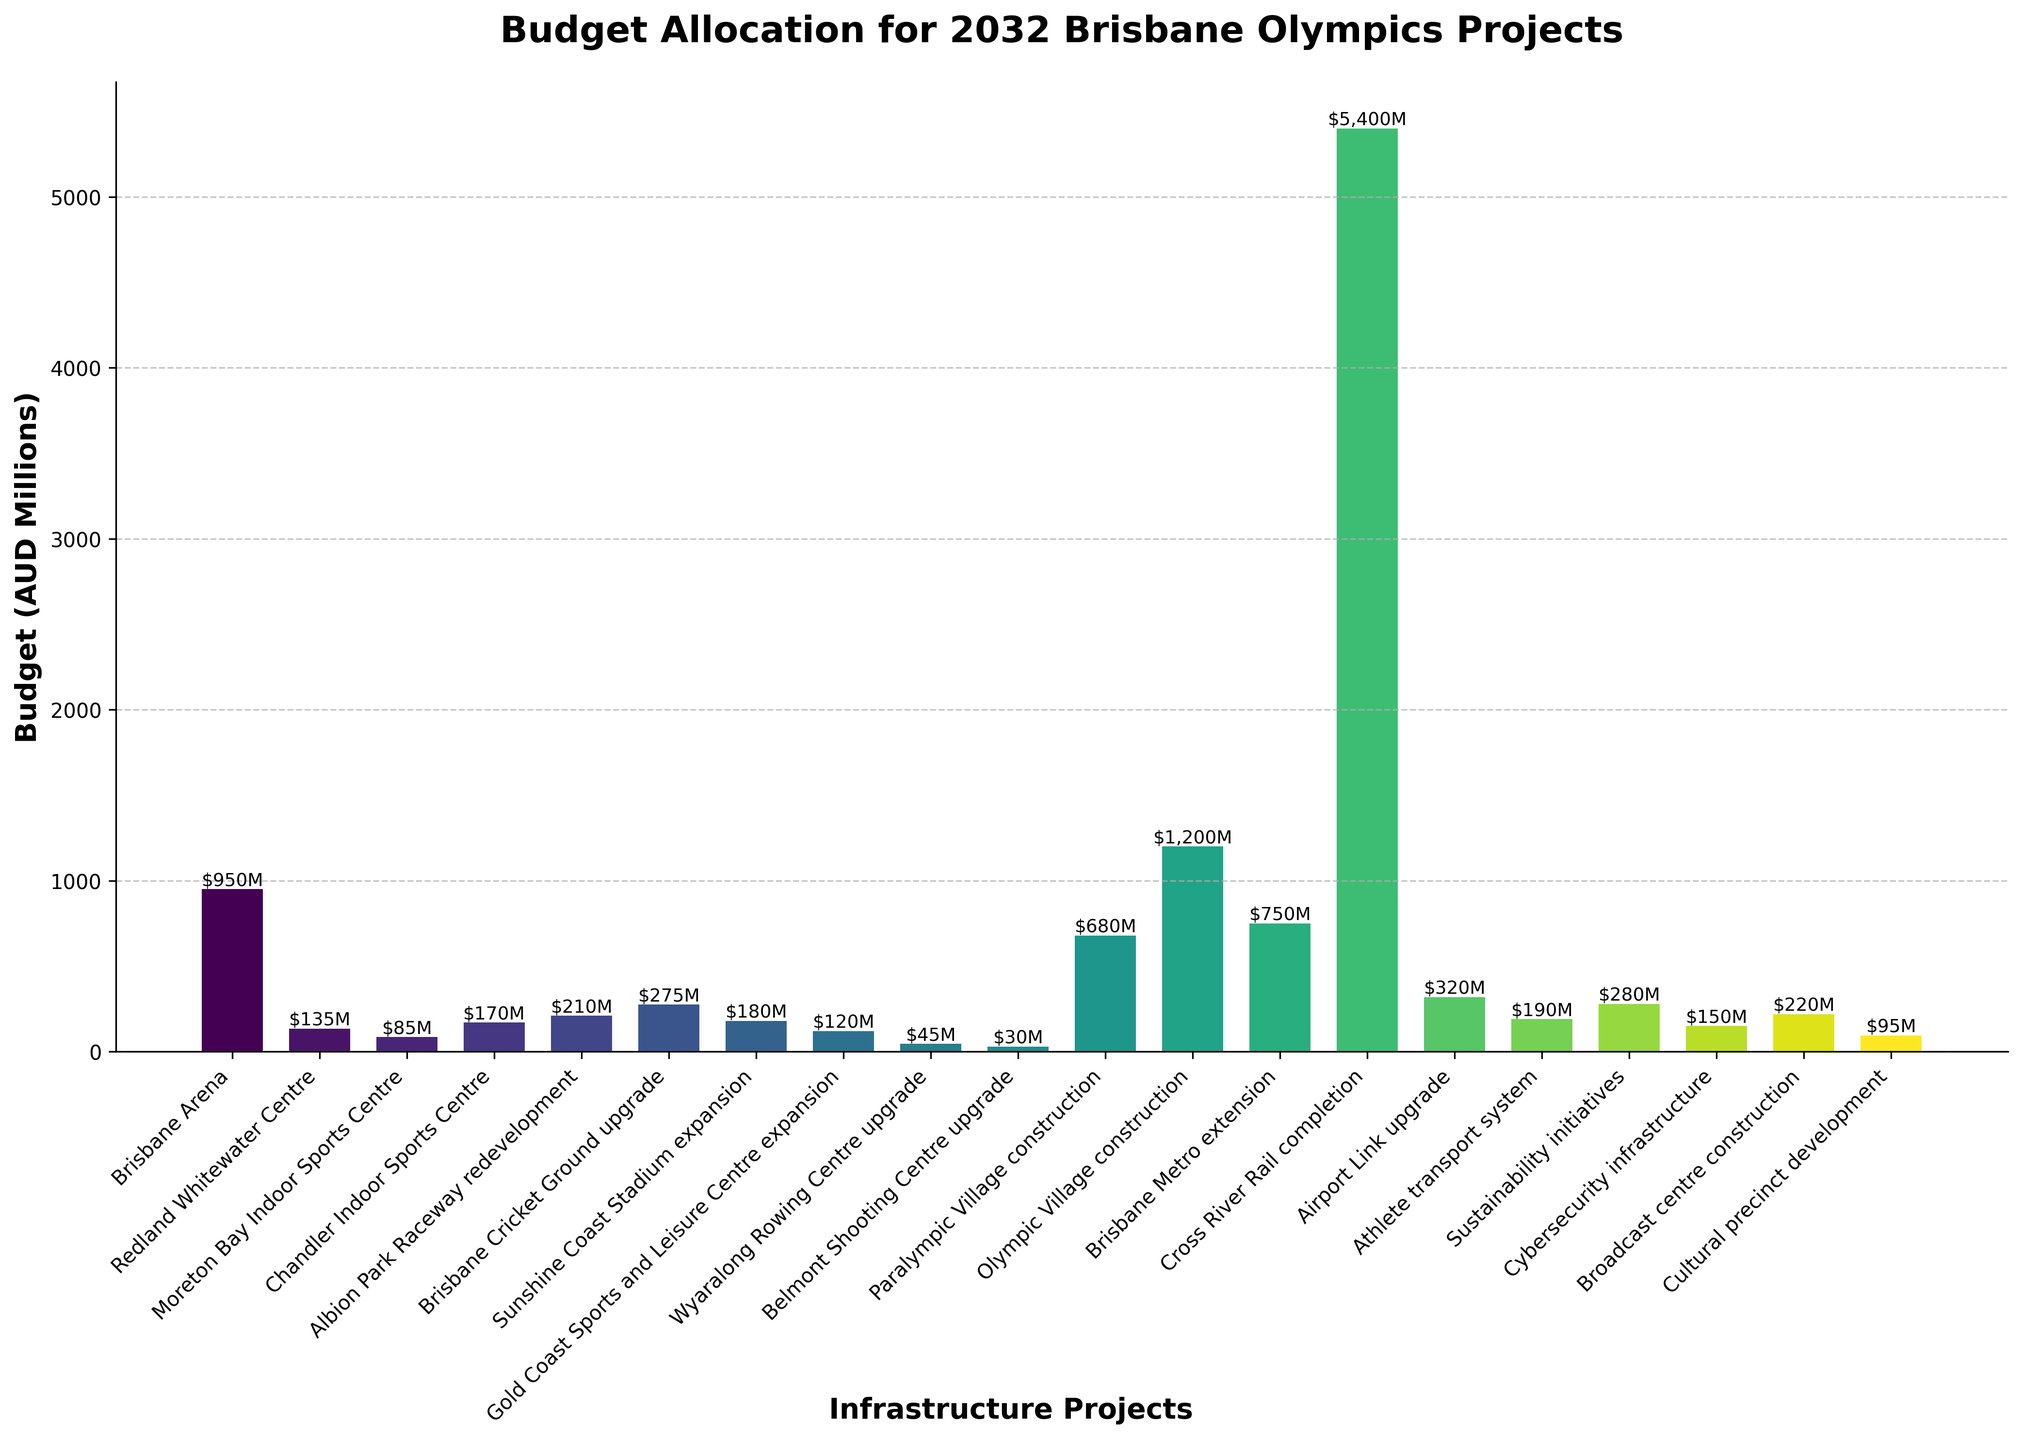Which project has the highest budget allocation? By looking at the heights of all the bars, the tallest bar corresponds to the Cross River Rail completion project, with a budget allocation of 5400 AUD millions.
Answer: Cross River Rail completion Which project has the second highest budget allocation after the Cross River Rail completion? After the Cross River Rail completion, the bar for the Olympic Village construction is the next tallest, indicating it has the second-highest budget allocation of 1200 AUD millions.
Answer: Olympic Village construction What is the total budget allocation for the Brisbane Arena and Brisbane Cricket Ground upgrade combined? First, identify the budgets for Brisbane Arena and Brisbane Cricket Ground upgrade, which are 950 and 275 AUD millions respectively. Adding them together gives 950 + 275 = 1225 AUD millions.
Answer: 1225 AUD millions Which project has a smaller budget allocation: Paralympic Village construction or Brisbane Metro extension? Comparing the heights of the bars for Paralympic Village construction (680 AUD millions) and Brisbane Metro extension (750 AUD millions), the Paralympic Village construction has a smaller budget allocation.
Answer: Paralympic Village construction What's the difference in budget allocation between the Wyaralong Rowing Centre upgrade and Belmont Shooting Centre upgrade? The budget for Wyaralong Rowing Centre upgrade is 45 AUD millions and for Belmont Shooting Centre upgrade is 30 AUD millions. The difference is 45 - 30 = 15 AUD millions.
Answer: 15 AUD millions How many projects have a budget allocation of less than 100 AUD millions? Counting the bars that are shorter than the 100 AUD millions mark, we find that there are three such projects: Moreton Bay Indoor Sports Centre, Wyaralong Rowing Centre upgrade, and Belmont Shooting Centre upgrade.
Answer: 3 projects What is the average budget allocation for the projects related to sports centres and arenas? The relevant projects and their budgets are Brisbane Arena (950), Redland Whitewater Centre (135), Moreton Bay Indoor Sports Centre (85), Chandler Indoor Sports Centre (170), Albion Park Raceway redevelopment (210), Sunshine Coast Stadium expansion (180), and Gold Coast Sports and Leisure Centre expansion (120). Adding these gives: 950 + 135 + 85 + 170 + 210 + 180 + 120 = 1850. Dividing by 7 gives an average of 1850 / 7 ≈ 264.29 AUD millions.
Answer: 264.29 AUD millions Which three projects have the lowest budget allocations? By looking at the shortest bars, the three projects with the lowest budget allocations are Belmont Shooting Centre upgrade (30), Wyaralong Rowing Centre upgrade (45), and Moreton Bay Indoor Sports Centre (85) AUD millions.
Answer: Belmont Shooting Centre upgrade, Wyaralong Rowing Centre upgrade, Moreton Bay Indoor Sports Centre Is the budget for Cybersecurity infrastructure higher or lower than the budget for Sustainability initiatives? By comparing the heights of the bars, we see that Cybersecurity infrastructure (150 AUD millions) has a lower budget than Sustainability initiatives (280 AUD millions).
Answer: Lower What is the total budget allocation for the cultural projects (including Cultural precinct development and Broadcast centre construction)? The relevant projects and their budgets are Cultural precinct development (95) and Broadcast centre construction (220). Adding these gives: 95 + 220 = 315 AUD millions.
Answer: 315 AUD millions 